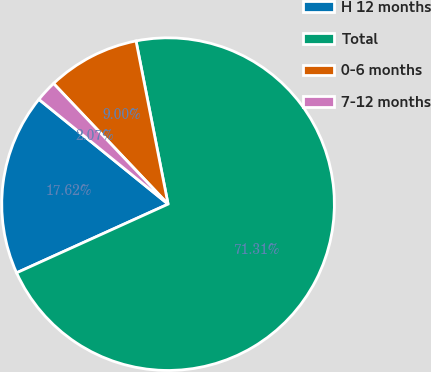Convert chart. <chart><loc_0><loc_0><loc_500><loc_500><pie_chart><fcel>H 12 months<fcel>Total<fcel>0-6 months<fcel>7-12 months<nl><fcel>17.62%<fcel>71.31%<fcel>9.0%<fcel>2.07%<nl></chart> 